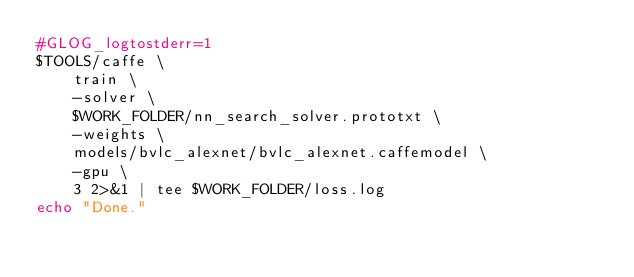<code> <loc_0><loc_0><loc_500><loc_500><_Bash_>#GLOG_logtostderr=1     
$TOOLS/caffe \
    train \
    -solver \
    $WORK_FOLDER/nn_search_solver.prototxt \
    -weights \
    models/bvlc_alexnet/bvlc_alexnet.caffemodel \
    -gpu \
    3 2>&1 | tee $WORK_FOLDER/loss.log
echo "Done."</code> 